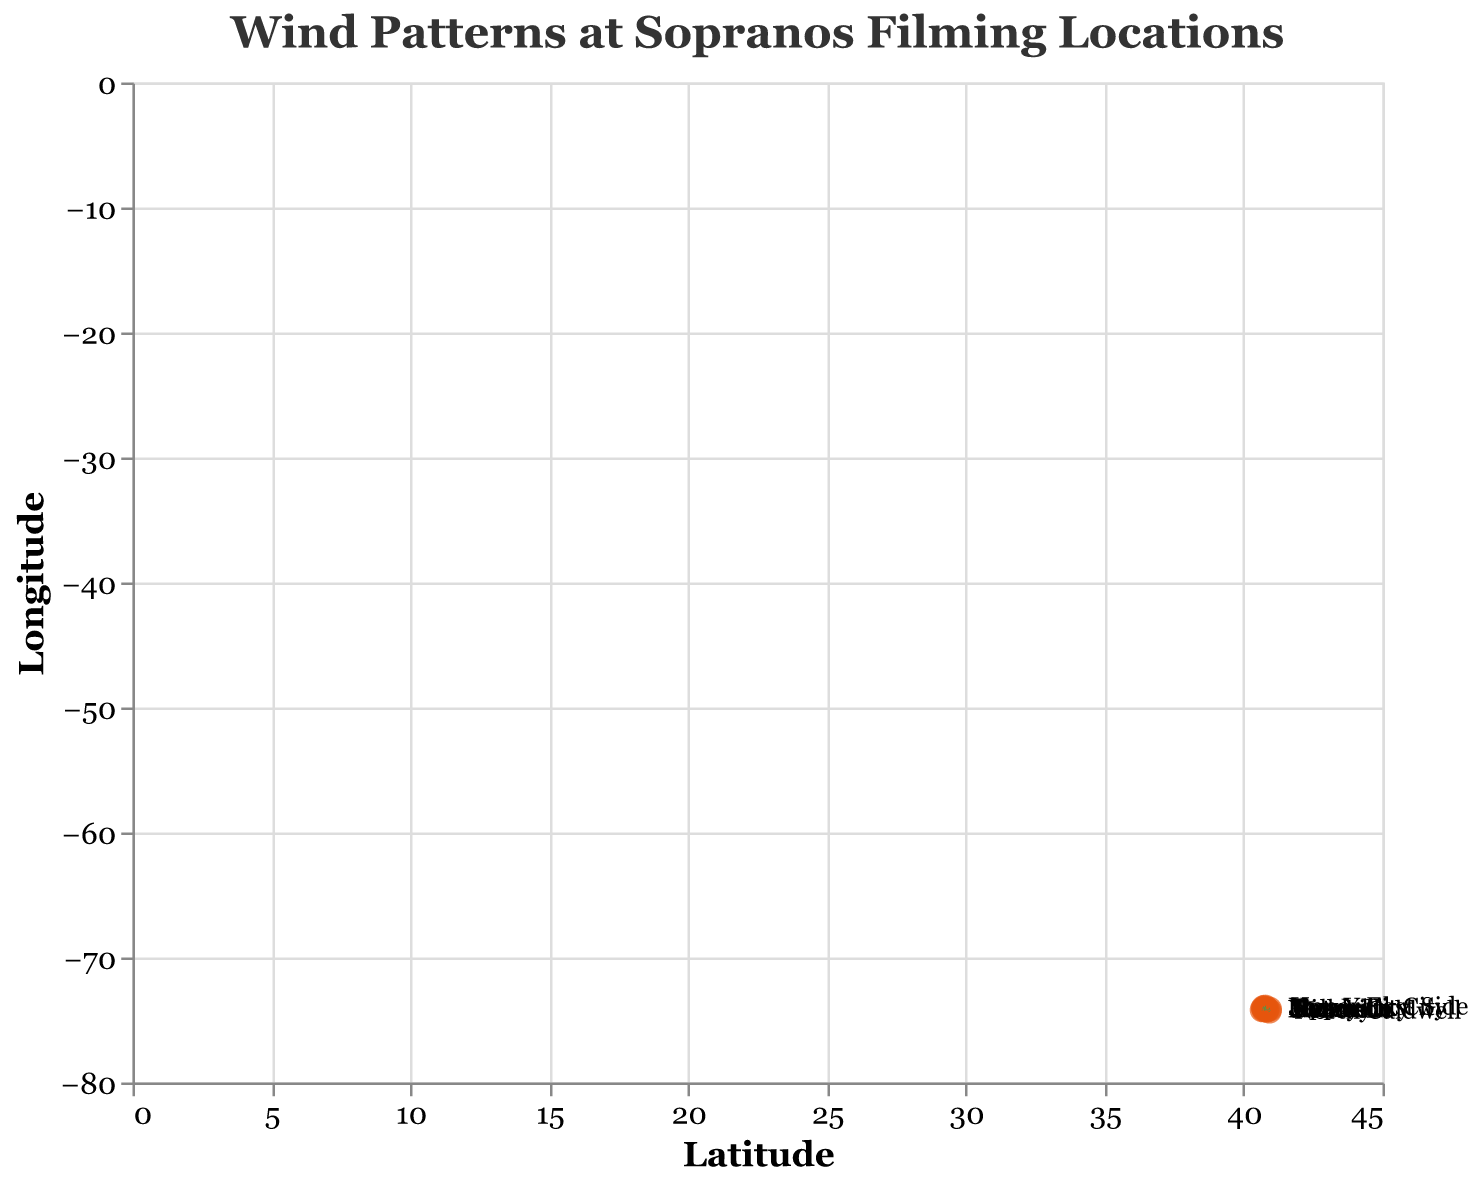What is the title of the quiver plot? The title is usually the largest text at the top of the plot, which gives a general idea of what the plot is about. Here, it reads "Wind Patterns at Sopranos Filming Locations".
Answer: Wind Patterns at Sopranos Filming Locations How many filming locations are displayed on the plot? Count the number of distinct points or labeled data points in the figure. Each point represents a location.
Answer: 10 Which location experiences the strongest wind intensity in the positive x-direction? Look for the location with the largest positive x-component (u) of the wind vector. Here, Jersey City and Upper East Side both have a u value of 3, but only one can be selected.
Answer: Jersey City Which location has a wind vector pointing south-east? A south-east direction means a positive y-component (v) and a negative x-component (u). Identify such a vector in the plot.
Answer: Belleville What is the direction of the wind vector at New York City? The wind direction is given by the vector components. For New York City, u is -2 and v is 1, indicating a movement toward the south-west.
Answer: South-West Compare the wind patterns in Newark and Paterson. Which one has a stronger y-component of the wind vector? Compare the absolute values of the y-components (v) for both locations. Newark is 1 and Paterson is 2. Since 2 is greater than 1, Paterson has a stronger y-component.
Answer: Paterson What is the sum of the x-components of all wind vectors on the plot? Sum all the u values: (−2 + 1 + 3 − 1 + 2 − 3 + 1 − 2 + 3 − 1) = 1.
Answer: 1 Which direction does the wind vector in Secaucus point to? The wind vector components for Secaucus are u = -2 and v = -3, indicating directional movement towards the south-west.
Answer: South-West Which location has the smallest magnitude of wind vector? Calculate the magnitudes of all vectors using sqrt(u^2 + v^2) and find the smallest. Here, Newark has u=2 and v=1, so magnitude ≈ sqrt(2^2 + 1^2) = sqrt(5) ≈ 2.24. Other magnitudes are larger.
Answer: Newark What is the average y-component of the wind vector of all filming locations? Sum up all y-component values and divide by the number of locations. (1 + (-3) + 2 + (-2) + 1 + 2 + (-1) + (-3) + 1 + 2) / 10 = 0.
Answer: 0 